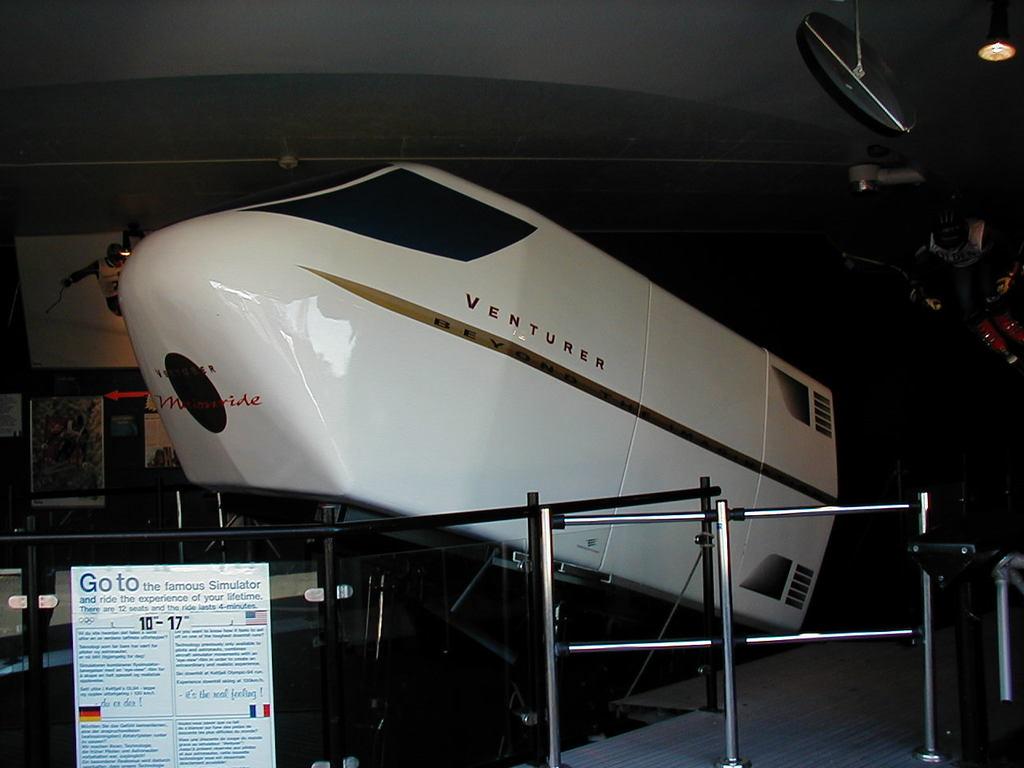What is the name of the simulator?
Keep it short and to the point. Venturer. What is the first word on the sign in front of the simulator?
Give a very brief answer. Go. 